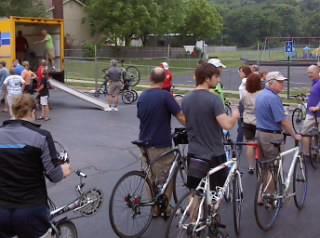Where are most of the people's attention focused?
Write a very short answer. Truck. Are all these people holding bicycles?
Short answer required. Yes. Are the two bikes the same general type?
Give a very brief answer. Yes. Can these men easily fall off the bike?
Give a very brief answer. No. Who is walking the dog?
Keep it brief. No one. Are the roads crowded?
Be succinct. Yes. What are the people riding?
Quick response, please. Bikes. Does the man have a shopping basket on his bike?
Keep it brief. No. Is there a red bike in the center of the crowd?
Concise answer only. No. What delivery truck is in the background?
Concise answer only. Penske. How many people have hats?
Be succinct. 2. Are they racing?
Give a very brief answer. No. How many bicycles are in the photo?
Keep it brief. 5. What color is the moving truck?
Be succinct. Yellow. What is coming out the back of the moving truck?
Be succinct. Ramp. 